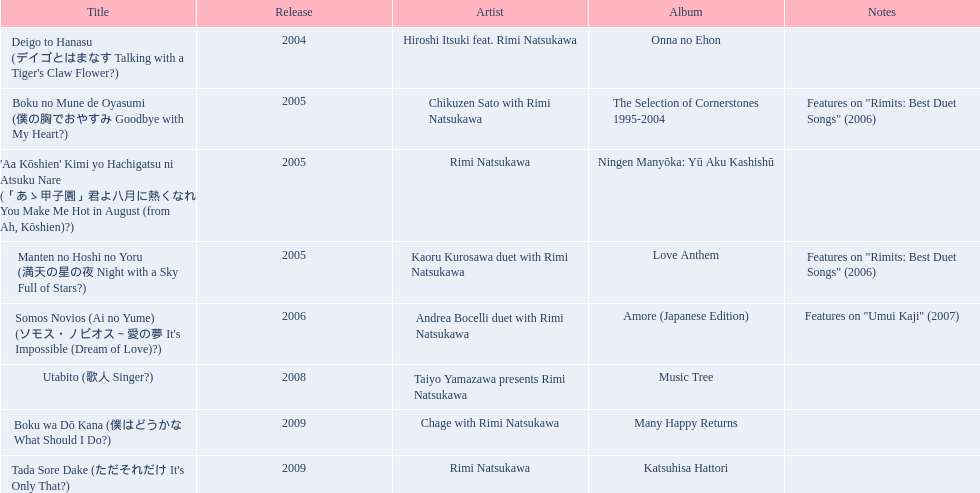Which title of the rimi natsukawa discography was released in the 2004? Deigo to Hanasu (デイゴとはまなす Talking with a Tiger's Claw Flower?). Which title has notes that features on/rimits. best duet songs\2006 Manten no Hoshi no Yoru (満天の星の夜 Night with a Sky Full of Stars?). Which title share the same notes as night with a sky full of stars? Boku no Mune de Oyasumi (僕の胸でおやすみ Goodbye with My Heart?). Can you give me this table in json format? {'header': ['Title', 'Release', 'Artist', 'Album', 'Notes'], 'rows': [["Deigo to Hanasu (デイゴとはまなす Talking with a Tiger's Claw Flower?)", '2004', 'Hiroshi Itsuki feat. Rimi Natsukawa', 'Onna no Ehon', ''], ['Boku no Mune de Oyasumi (僕の胸でおやすみ Goodbye with My Heart?)', '2005', 'Chikuzen Sato with Rimi Natsukawa', 'The Selection of Cornerstones 1995-2004', 'Features on "Rimits: Best Duet Songs" (2006)'], ["'Aa Kōshien' Kimi yo Hachigatsu ni Atsuku Nare (「あゝ甲子園」君よ八月に熱くなれ You Make Me Hot in August (from Ah, Kōshien)?)", '2005', 'Rimi Natsukawa', 'Ningen Manyōka: Yū Aku Kashishū', ''], ['Manten no Hoshi no Yoru (満天の星の夜 Night with a Sky Full of Stars?)', '2005', 'Kaoru Kurosawa duet with Rimi Natsukawa', 'Love Anthem', 'Features on "Rimits: Best Duet Songs" (2006)'], ["Somos Novios (Ai no Yume) (ソモス・ノビオス～愛の夢 It's Impossible (Dream of Love)?)", '2006', 'Andrea Bocelli duet with Rimi Natsukawa', 'Amore (Japanese Edition)', 'Features on "Umui Kaji" (2007)'], ['Utabito (歌人 Singer?)', '2008', 'Taiyo Yamazawa presents Rimi Natsukawa', 'Music Tree', ''], ['Boku wa Dō Kana (僕はどうかな What Should I Do?)', '2009', 'Chage with Rimi Natsukawa', 'Many Happy Returns', ''], ["Tada Sore Dake (ただそれだけ It's Only That?)", '2009', 'Rimi Natsukawa', 'Katsuhisa Hattori', '']]} 